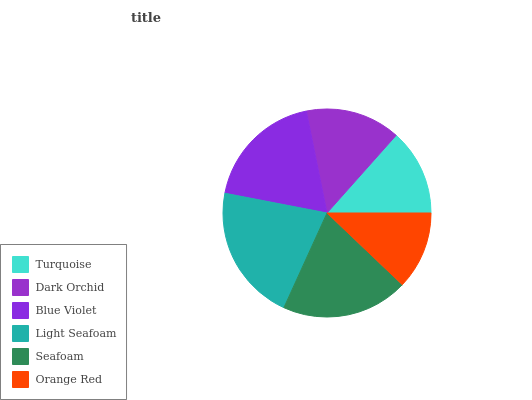Is Orange Red the minimum?
Answer yes or no. Yes. Is Light Seafoam the maximum?
Answer yes or no. Yes. Is Dark Orchid the minimum?
Answer yes or no. No. Is Dark Orchid the maximum?
Answer yes or no. No. Is Dark Orchid greater than Turquoise?
Answer yes or no. Yes. Is Turquoise less than Dark Orchid?
Answer yes or no. Yes. Is Turquoise greater than Dark Orchid?
Answer yes or no. No. Is Dark Orchid less than Turquoise?
Answer yes or no. No. Is Blue Violet the high median?
Answer yes or no. Yes. Is Dark Orchid the low median?
Answer yes or no. Yes. Is Seafoam the high median?
Answer yes or no. No. Is Seafoam the low median?
Answer yes or no. No. 